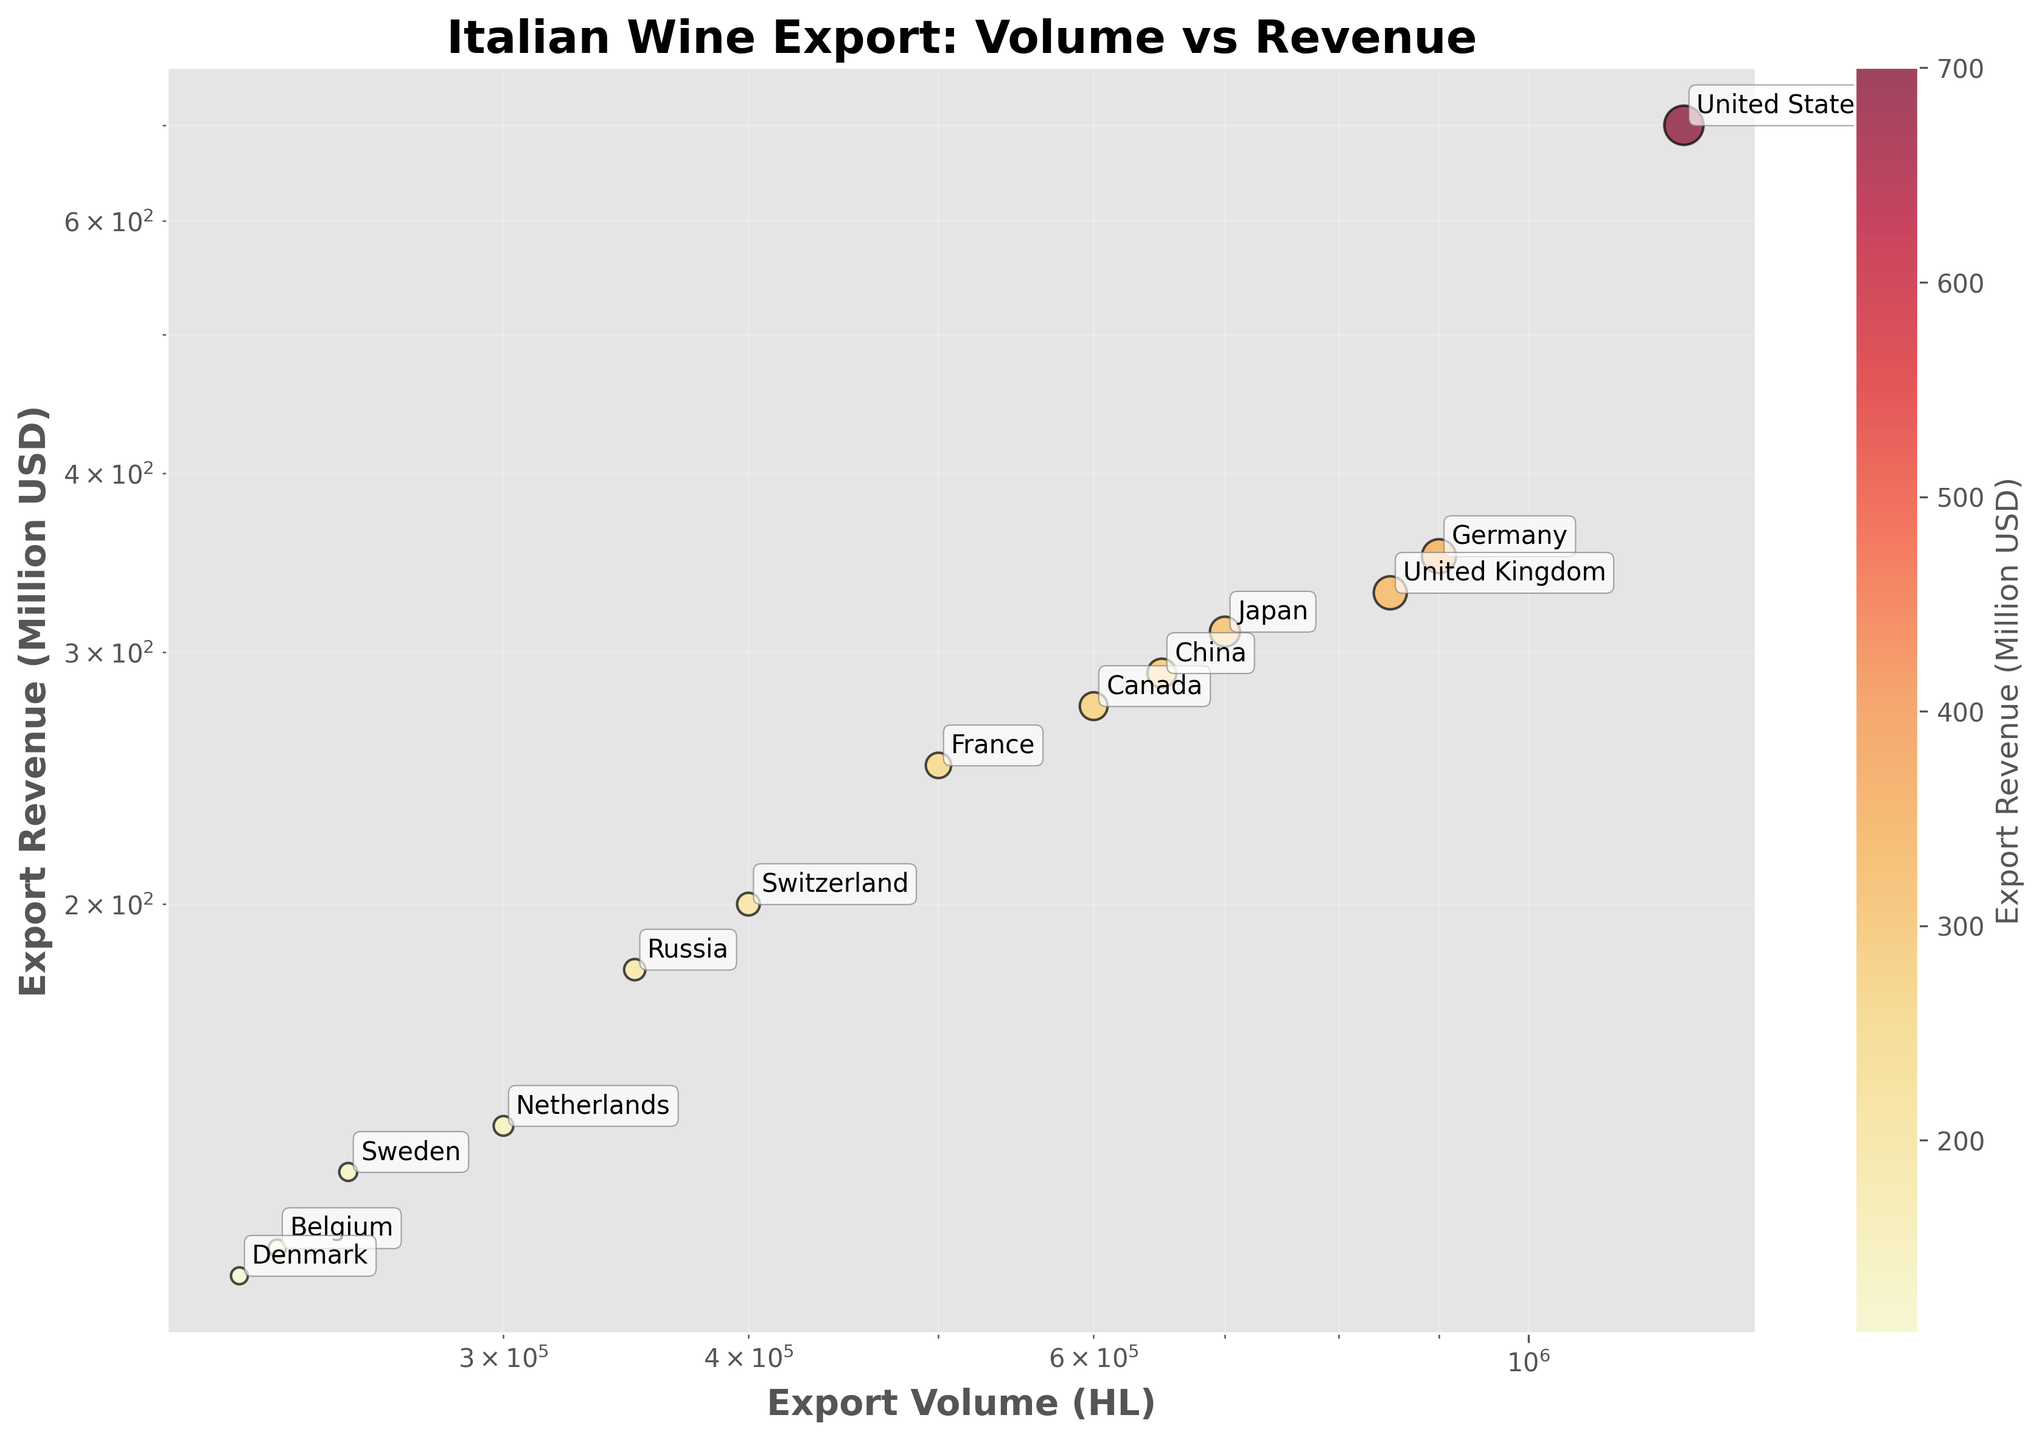What is the title of the scatter plot? The title is found at the top of the chart and is usually in a larger, bold font to highlight the focus of the graph. In this case, you can read it directly from the graph.
Answer: Italian Wine Export: Volume vs Revenue What do the log scales on the axes represent? Log scales are used to represent data that spans several orders of magnitude, making it easier to visualize relationships that cover a wide range. On this plot, the log scale shows export volume in hectoliters on the x-axis and export revenue in million USD on the y-axis, compressing large values more effectively and making patterns clearer.
Answer: Export Volume (HL) and Export Revenue (Million USD) Which country has the highest export revenue? Look for the highest point on the y-axis, which is labeled according to revenue. The country near this point is annotated directly on the plot.
Answer: United States How many countries have an export volume greater than 500,000 HL? Count the data points to the right of the 500,000 HL mark on the x-axis log scale. The data points have labels corresponding to the countries.
Answer: 7 Compare the export revenues of Canada and France. Which country has higher export revenue and by how much? Locate the points corresponding to Canada and France on the plot. Compare their positions on the y-axis (export revenue). Subtract France's revenue from Canada's to find the difference.
Answer: Canada; 275 - 250 = 25 Million USD Which country exports the least volume of Italian wine? Identify the data point marked with the smallest value on the x-axis (export volume). The corresponding country will be labeled next to the point.
Answer: Denmark Calculate the total export volume of Italian wines for the United States, Germany, and the United Kingdom. Locate the export volumes for these three countries and add them up. The volumes can be read off the x-axis, and the countries are labeled next to their respective data points.
Answer: 1200000 + 900000 + 850000 = 2950000 HL Is there any country with an export volume of around 500,000 HL and what is its export revenue? Look for a data point close to 500,000 HL on the x-axis. Identify which country it is, and then note its corresponding revenue on the y-axis.
Answer: France; 250 Million USD Which country has a similar export revenue to Japan, and what is the slight difference in their export volumes? Find Japan on the plot, then look for neighboring points on the y-axis that represent similar revenues. Compare their x-axis values to find the export volumes and calculate the difference.
Answer: China; 700000 - 650000 = 50000 HL 